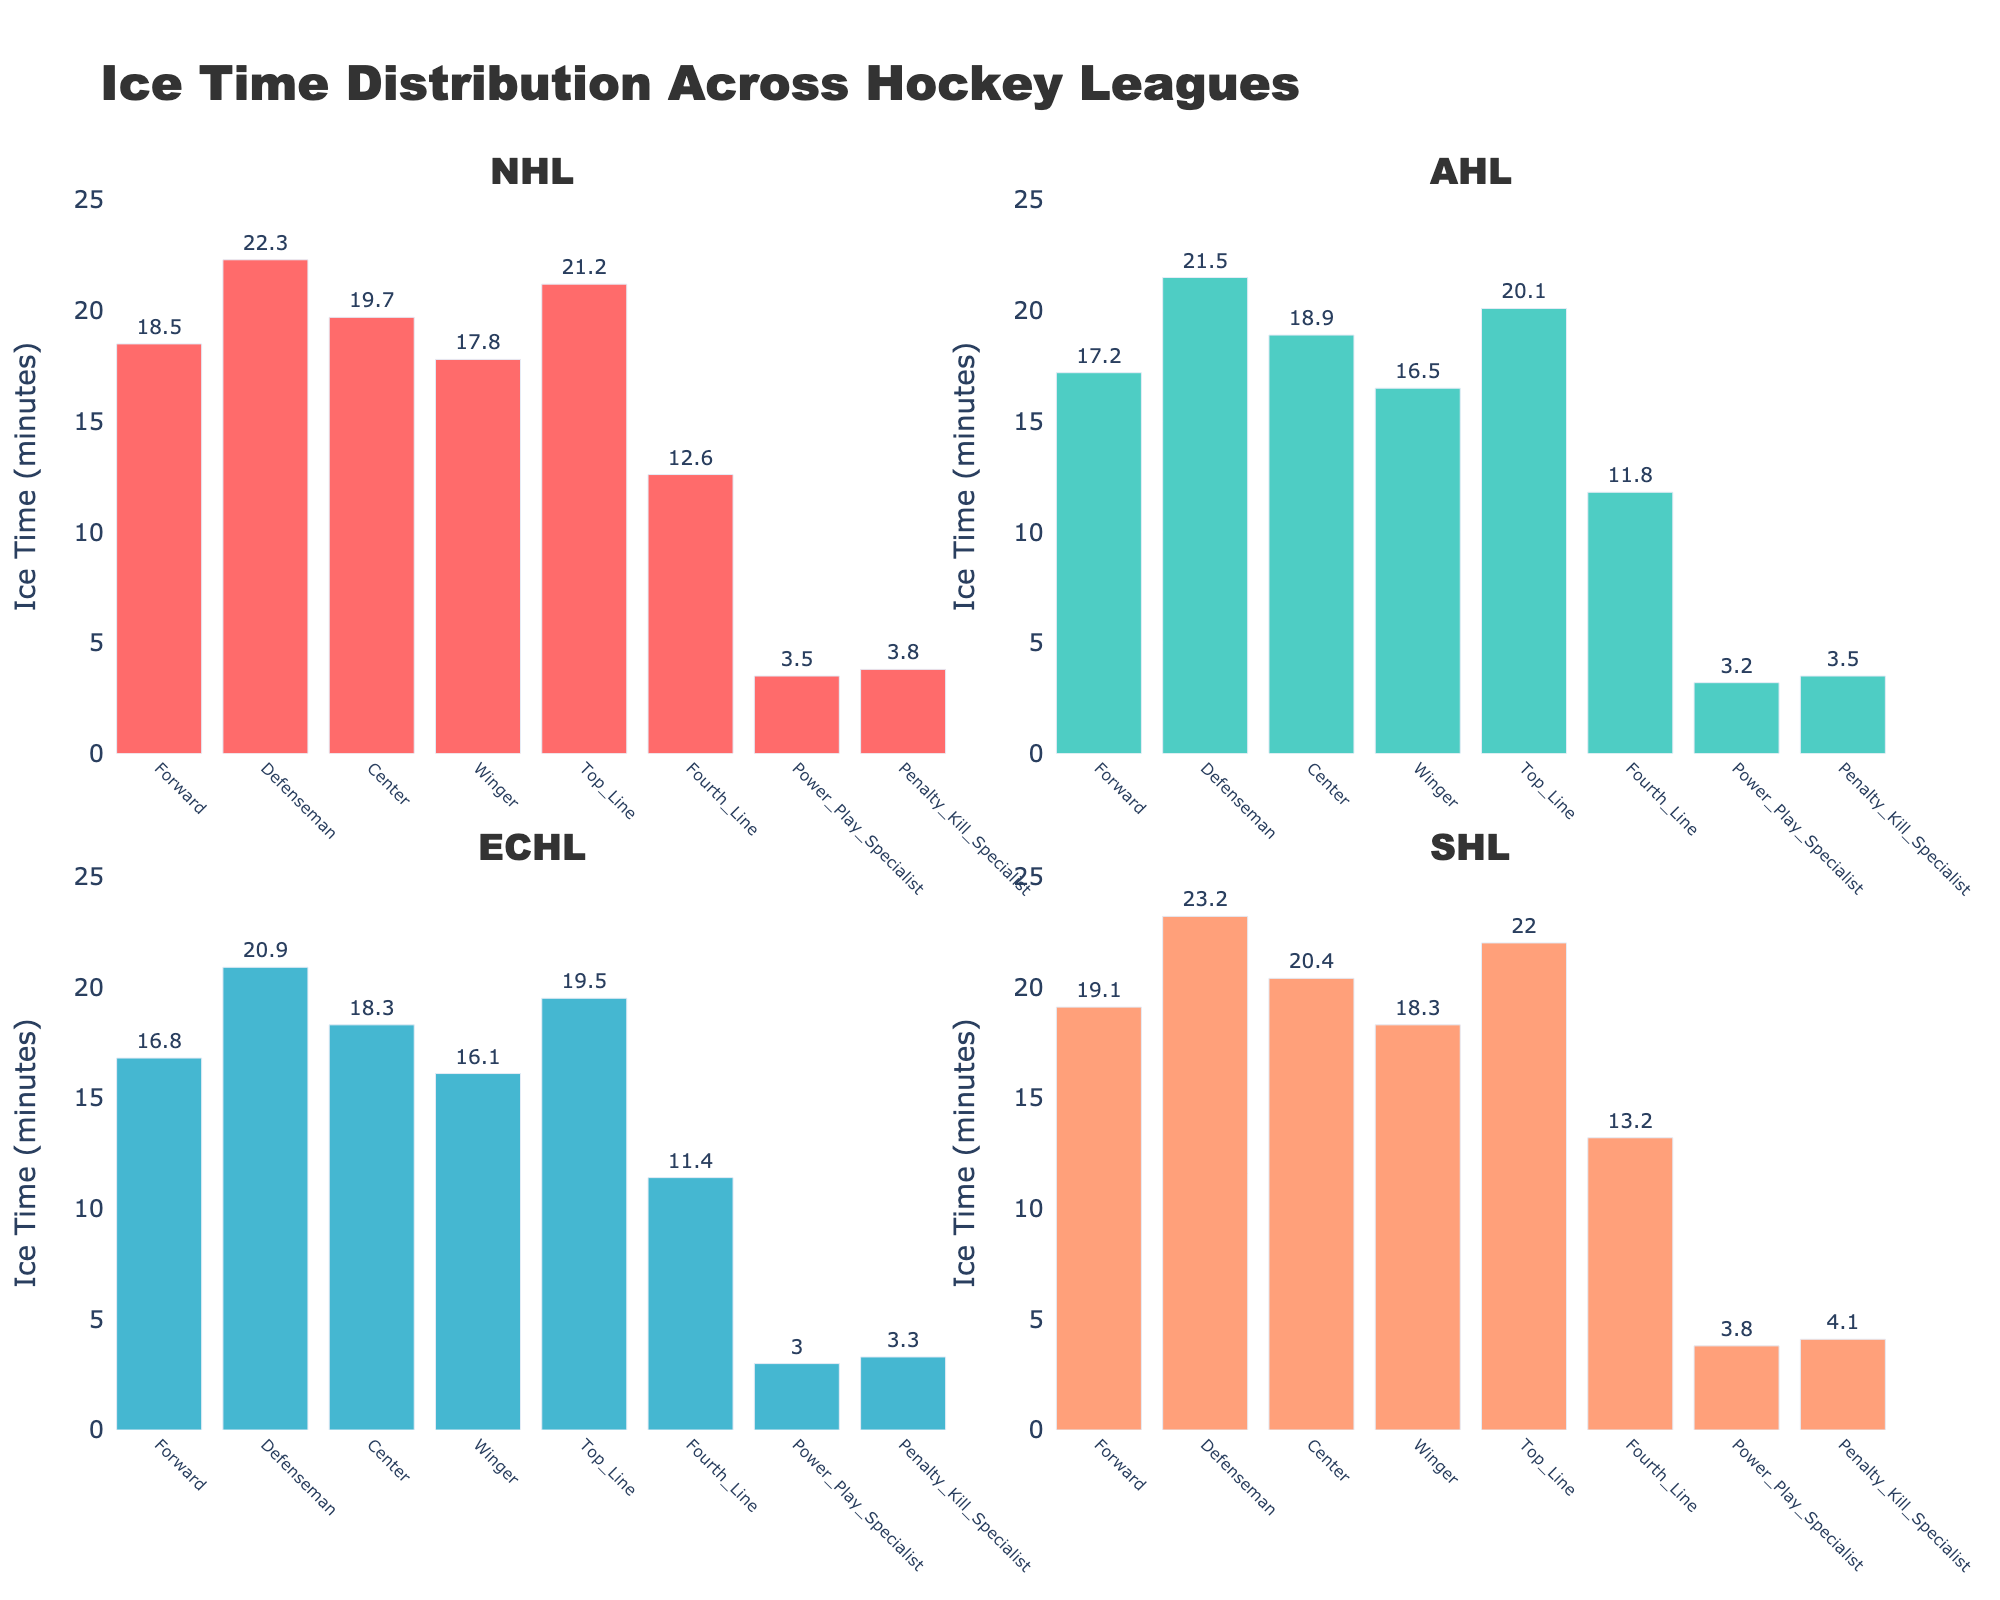What is the title of the figure? The title of the figure is situated at the top and reads "Ice Time Distribution Across Hockey Leagues".
Answer: Ice Time Distribution Across Hockey Leagues What is the average ice time for all player roles in the NHL? To find the average ice time for all player roles in the NHL, sum the values and divide by the number of roles: (18.5 + 22.3 + 19.7 + 17.8 + 21.2 + 12.6 + 3.5 + 3.8) / 8 = 15.675
Answer: 15.675 Which player role has the highest ice time in SHL? By examining the bars in the SHL subplot, the Defenseman role has the highest ice time value of 23.2 minutes.
Answer: Defenseman How does the Power_Play_Specialist role compare between AHL and NHL? The Power_Play_Specialist role has 3.2 minutes of ice time in the AHL and 3.5 minutes in the NHL. Therefore, the NHL value is higher by 0.3 minutes.
Answer: The NHL is higher by 0.3 minutes What are the ice time ranges for the Forward role across all leagues? The ice times for the Forward role in each league are: NHL: 18.5, AHL: 17.2, ECHL: 16.8, SHL: 19.1. The range is from 16.8 to 19.1 minutes.
Answer: 16.8 to 19.1 minutes Which league has the least ice time for the Fourth_Line role? In the Fourth_Line role, the ice times are as follows: NHL: 12.6, AHL: 11.8, ECHL: 11.4, SHL: 13.2. The ECHL has the least ice time at 11.4 minutes.
Answer: ECHL Among NHL, AHL, and SHL, which player role has the most significant increase in ice time from AHL to SHL? By comparing each player role's ice times from AHL to SHL, Penalty_Kill_Specialist shows the most significant increase: SHL (4.1) - AHL (3.5) = 0.6 minutes.
Answer: Penalty_Kill_Specialist Is the average ice time for Defenseman higher in ECHL or SHL? The ice time for Defenseman in ECHL is 20.9 minutes, while in SHL it is 23.2 minutes. Thus, the average time is higher in SHL.
Answer: SHL Calculate the total ice time for Top_Line and Fourth_Line roles in AHL. Adding the ice times for Top_Line (20.1) and Fourth_Line (11.8) roles in AHL: 20.1 + 11.8 = 31.9 minutes.
Answer: 31.9 minutes 